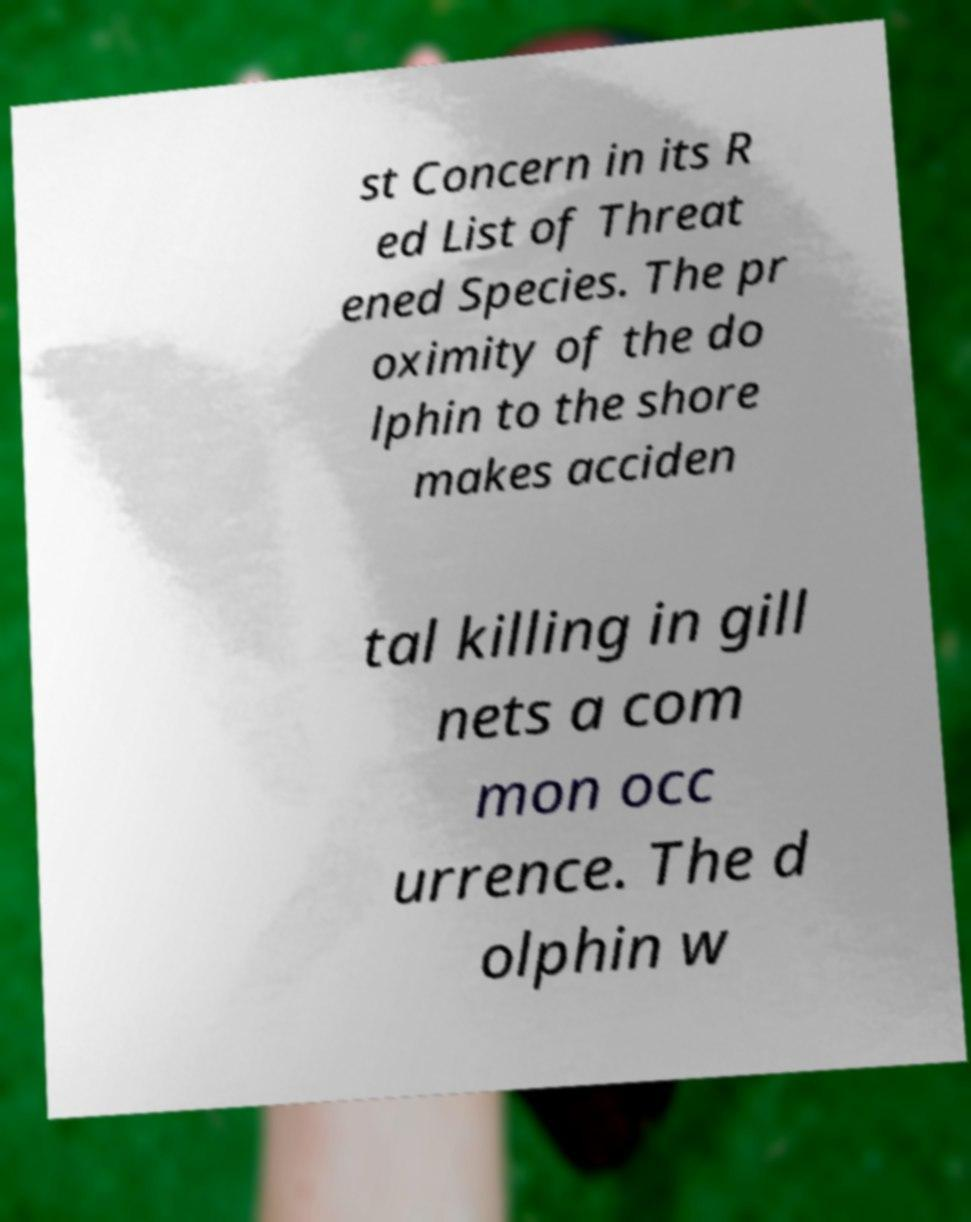Please read and relay the text visible in this image. What does it say? st Concern in its R ed List of Threat ened Species. The pr oximity of the do lphin to the shore makes acciden tal killing in gill nets a com mon occ urrence. The d olphin w 